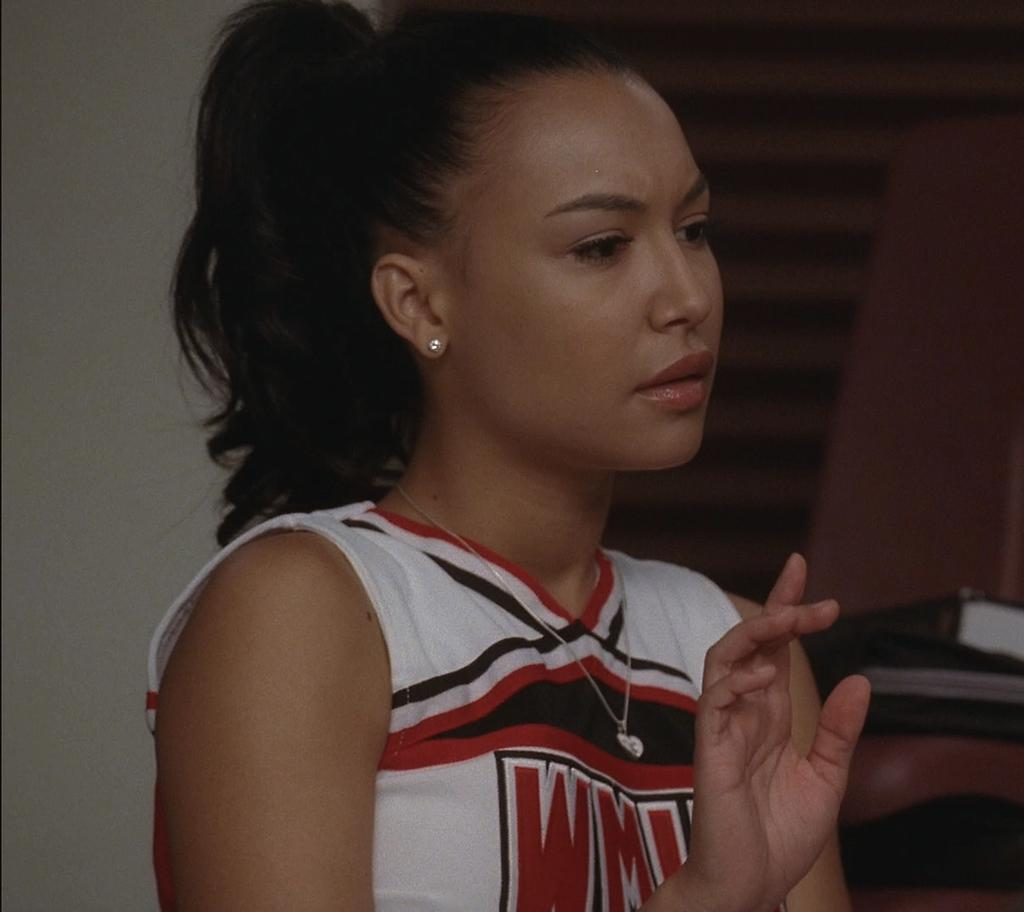Provide a one-sentence caption for the provided image. Black, red, and white cheer uniform with letters WM wrote in red. 